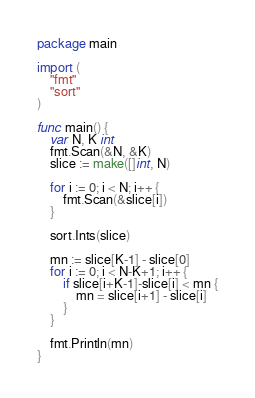<code> <loc_0><loc_0><loc_500><loc_500><_Go_>package main

import (
	"fmt"
	"sort"
)

func main() {
	var N, K int
	fmt.Scan(&N, &K)
	slice := make([]int, N)

	for i := 0; i < N; i++ {
		fmt.Scan(&slice[i])
	}

	sort.Ints(slice)

	mn := slice[K-1] - slice[0]
	for i := 0; i < N-K+1; i++ {
		if slice[i+K-1]-slice[i] < mn {
			mn = slice[i+1] - slice[i]
		}
	}

	fmt.Println(mn)
}
</code> 